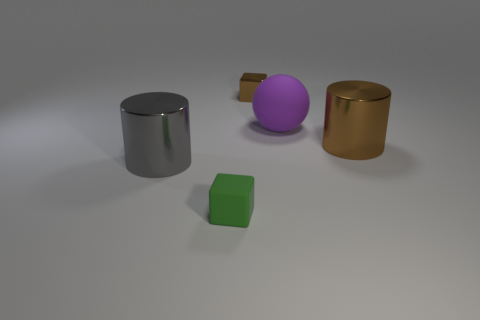Subtract all green cubes. How many cubes are left? 1 Subtract all cylinders. How many objects are left? 3 Subtract 1 spheres. How many spheres are left? 0 Subtract all green spheres. How many gray cylinders are left? 1 Subtract all rubber cubes. Subtract all large yellow balls. How many objects are left? 4 Add 1 small brown metal blocks. How many small brown metal blocks are left? 2 Add 5 green cubes. How many green cubes exist? 6 Add 2 big blue rubber cylinders. How many objects exist? 7 Subtract 0 red balls. How many objects are left? 5 Subtract all red cylinders. Subtract all green blocks. How many cylinders are left? 2 